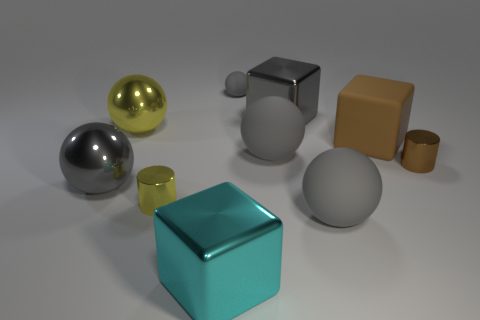The gray shiny sphere has what size?
Give a very brief answer. Large. Does the brown cylinder have the same size as the matte sphere in front of the tiny brown metal cylinder?
Offer a terse response. No. There is a shiny cylinder on the right side of the shiny cube that is in front of the gray metallic ball; what is its color?
Keep it short and to the point. Brown. Is the number of small rubber balls behind the small sphere the same as the number of yellow metal spheres right of the big cyan shiny cube?
Your answer should be very brief. Yes. Does the gray thing left of the tiny gray object have the same material as the big gray block?
Your response must be concise. Yes. What is the color of the shiny thing that is behind the small brown metallic object and on the left side of the big gray cube?
Keep it short and to the point. Yellow. There is a brown matte object that is in front of the gray shiny cube; what number of small yellow metallic things are right of it?
Your answer should be very brief. 0. There is a big yellow object that is the same shape as the small gray object; what is its material?
Your answer should be very brief. Metal. What color is the tiny rubber thing?
Provide a succinct answer. Gray. How many things are tiny gray matte objects or brown matte things?
Ensure brevity in your answer.  2. 